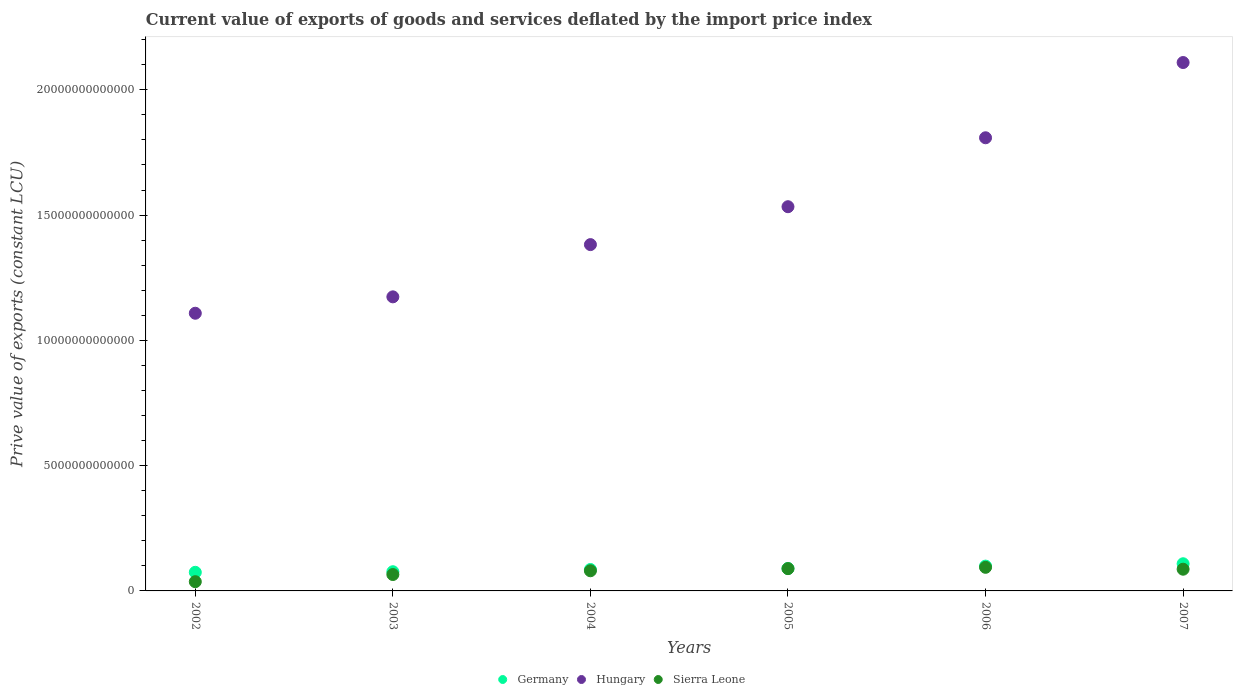What is the prive value of exports in Germany in 2005?
Make the answer very short. 8.96e+11. Across all years, what is the maximum prive value of exports in Germany?
Offer a very short reply. 1.08e+12. Across all years, what is the minimum prive value of exports in Sierra Leone?
Make the answer very short. 3.69e+11. In which year was the prive value of exports in Sierra Leone minimum?
Offer a terse response. 2002. What is the total prive value of exports in Sierra Leone in the graph?
Your answer should be very brief. 4.52e+12. What is the difference between the prive value of exports in Germany in 2003 and that in 2005?
Offer a terse response. -1.30e+11. What is the difference between the prive value of exports in Sierra Leone in 2004 and the prive value of exports in Germany in 2007?
Offer a terse response. -2.80e+11. What is the average prive value of exports in Hungary per year?
Offer a very short reply. 1.52e+13. In the year 2006, what is the difference between the prive value of exports in Hungary and prive value of exports in Sierra Leone?
Offer a very short reply. 1.71e+13. What is the ratio of the prive value of exports in Hungary in 2004 to that in 2006?
Provide a short and direct response. 0.76. What is the difference between the highest and the second highest prive value of exports in Germany?
Provide a short and direct response. 9.41e+1. What is the difference between the highest and the lowest prive value of exports in Hungary?
Offer a very short reply. 1.00e+13. Does the prive value of exports in Hungary monotonically increase over the years?
Offer a terse response. Yes. Is the prive value of exports in Sierra Leone strictly less than the prive value of exports in Germany over the years?
Keep it short and to the point. Yes. How many dotlines are there?
Offer a terse response. 3. How many years are there in the graph?
Your answer should be very brief. 6. What is the difference between two consecutive major ticks on the Y-axis?
Ensure brevity in your answer.  5.00e+12. Are the values on the major ticks of Y-axis written in scientific E-notation?
Provide a short and direct response. No. Does the graph contain any zero values?
Make the answer very short. No. How many legend labels are there?
Offer a very short reply. 3. What is the title of the graph?
Your answer should be very brief. Current value of exports of goods and services deflated by the import price index. Does "Tuvalu" appear as one of the legend labels in the graph?
Offer a very short reply. No. What is the label or title of the Y-axis?
Your answer should be compact. Prive value of exports (constant LCU). What is the Prive value of exports (constant LCU) of Germany in 2002?
Your answer should be very brief. 7.43e+11. What is the Prive value of exports (constant LCU) in Hungary in 2002?
Your response must be concise. 1.11e+13. What is the Prive value of exports (constant LCU) in Sierra Leone in 2002?
Your answer should be very brief. 3.69e+11. What is the Prive value of exports (constant LCU) of Germany in 2003?
Give a very brief answer. 7.66e+11. What is the Prive value of exports (constant LCU) in Hungary in 2003?
Offer a very short reply. 1.17e+13. What is the Prive value of exports (constant LCU) in Sierra Leone in 2003?
Your answer should be compact. 6.54e+11. What is the Prive value of exports (constant LCU) of Germany in 2004?
Offer a terse response. 8.56e+11. What is the Prive value of exports (constant LCU) in Hungary in 2004?
Keep it short and to the point. 1.38e+13. What is the Prive value of exports (constant LCU) in Sierra Leone in 2004?
Offer a terse response. 8.04e+11. What is the Prive value of exports (constant LCU) of Germany in 2005?
Provide a succinct answer. 8.96e+11. What is the Prive value of exports (constant LCU) of Hungary in 2005?
Offer a terse response. 1.53e+13. What is the Prive value of exports (constant LCU) in Sierra Leone in 2005?
Keep it short and to the point. 8.90e+11. What is the Prive value of exports (constant LCU) of Germany in 2006?
Ensure brevity in your answer.  9.90e+11. What is the Prive value of exports (constant LCU) of Hungary in 2006?
Your response must be concise. 1.81e+13. What is the Prive value of exports (constant LCU) in Sierra Leone in 2006?
Give a very brief answer. 9.42e+11. What is the Prive value of exports (constant LCU) of Germany in 2007?
Provide a succinct answer. 1.08e+12. What is the Prive value of exports (constant LCU) of Hungary in 2007?
Your answer should be compact. 2.11e+13. What is the Prive value of exports (constant LCU) in Sierra Leone in 2007?
Offer a terse response. 8.66e+11. Across all years, what is the maximum Prive value of exports (constant LCU) in Germany?
Provide a short and direct response. 1.08e+12. Across all years, what is the maximum Prive value of exports (constant LCU) in Hungary?
Make the answer very short. 2.11e+13. Across all years, what is the maximum Prive value of exports (constant LCU) of Sierra Leone?
Your answer should be compact. 9.42e+11. Across all years, what is the minimum Prive value of exports (constant LCU) in Germany?
Offer a very short reply. 7.43e+11. Across all years, what is the minimum Prive value of exports (constant LCU) of Hungary?
Offer a very short reply. 1.11e+13. Across all years, what is the minimum Prive value of exports (constant LCU) of Sierra Leone?
Your answer should be compact. 3.69e+11. What is the total Prive value of exports (constant LCU) of Germany in the graph?
Offer a very short reply. 5.34e+12. What is the total Prive value of exports (constant LCU) of Hungary in the graph?
Your answer should be compact. 9.12e+13. What is the total Prive value of exports (constant LCU) in Sierra Leone in the graph?
Keep it short and to the point. 4.52e+12. What is the difference between the Prive value of exports (constant LCU) of Germany in 2002 and that in 2003?
Your answer should be compact. -2.31e+1. What is the difference between the Prive value of exports (constant LCU) of Hungary in 2002 and that in 2003?
Provide a succinct answer. -6.55e+11. What is the difference between the Prive value of exports (constant LCU) in Sierra Leone in 2002 and that in 2003?
Provide a succinct answer. -2.86e+11. What is the difference between the Prive value of exports (constant LCU) of Germany in 2002 and that in 2004?
Provide a succinct answer. -1.13e+11. What is the difference between the Prive value of exports (constant LCU) in Hungary in 2002 and that in 2004?
Ensure brevity in your answer.  -2.74e+12. What is the difference between the Prive value of exports (constant LCU) of Sierra Leone in 2002 and that in 2004?
Your answer should be compact. -4.35e+11. What is the difference between the Prive value of exports (constant LCU) in Germany in 2002 and that in 2005?
Your answer should be compact. -1.53e+11. What is the difference between the Prive value of exports (constant LCU) in Hungary in 2002 and that in 2005?
Provide a short and direct response. -4.25e+12. What is the difference between the Prive value of exports (constant LCU) in Sierra Leone in 2002 and that in 2005?
Make the answer very short. -5.21e+11. What is the difference between the Prive value of exports (constant LCU) of Germany in 2002 and that in 2006?
Offer a very short reply. -2.47e+11. What is the difference between the Prive value of exports (constant LCU) of Hungary in 2002 and that in 2006?
Your response must be concise. -7.00e+12. What is the difference between the Prive value of exports (constant LCU) of Sierra Leone in 2002 and that in 2006?
Your answer should be compact. -5.73e+11. What is the difference between the Prive value of exports (constant LCU) of Germany in 2002 and that in 2007?
Provide a short and direct response. -3.41e+11. What is the difference between the Prive value of exports (constant LCU) in Hungary in 2002 and that in 2007?
Your answer should be compact. -1.00e+13. What is the difference between the Prive value of exports (constant LCU) in Sierra Leone in 2002 and that in 2007?
Offer a very short reply. -4.98e+11. What is the difference between the Prive value of exports (constant LCU) of Germany in 2003 and that in 2004?
Your answer should be compact. -8.95e+1. What is the difference between the Prive value of exports (constant LCU) of Hungary in 2003 and that in 2004?
Offer a terse response. -2.08e+12. What is the difference between the Prive value of exports (constant LCU) in Sierra Leone in 2003 and that in 2004?
Your response must be concise. -1.50e+11. What is the difference between the Prive value of exports (constant LCU) of Germany in 2003 and that in 2005?
Keep it short and to the point. -1.30e+11. What is the difference between the Prive value of exports (constant LCU) of Hungary in 2003 and that in 2005?
Your response must be concise. -3.60e+12. What is the difference between the Prive value of exports (constant LCU) in Sierra Leone in 2003 and that in 2005?
Ensure brevity in your answer.  -2.35e+11. What is the difference between the Prive value of exports (constant LCU) in Germany in 2003 and that in 2006?
Provide a short and direct response. -2.24e+11. What is the difference between the Prive value of exports (constant LCU) of Hungary in 2003 and that in 2006?
Offer a very short reply. -6.35e+12. What is the difference between the Prive value of exports (constant LCU) in Sierra Leone in 2003 and that in 2006?
Give a very brief answer. -2.88e+11. What is the difference between the Prive value of exports (constant LCU) in Germany in 2003 and that in 2007?
Offer a terse response. -3.18e+11. What is the difference between the Prive value of exports (constant LCU) in Hungary in 2003 and that in 2007?
Provide a succinct answer. -9.35e+12. What is the difference between the Prive value of exports (constant LCU) of Sierra Leone in 2003 and that in 2007?
Provide a succinct answer. -2.12e+11. What is the difference between the Prive value of exports (constant LCU) in Germany in 2004 and that in 2005?
Offer a very short reply. -4.09e+1. What is the difference between the Prive value of exports (constant LCU) of Hungary in 2004 and that in 2005?
Make the answer very short. -1.51e+12. What is the difference between the Prive value of exports (constant LCU) in Sierra Leone in 2004 and that in 2005?
Ensure brevity in your answer.  -8.55e+1. What is the difference between the Prive value of exports (constant LCU) of Germany in 2004 and that in 2006?
Your response must be concise. -1.34e+11. What is the difference between the Prive value of exports (constant LCU) in Hungary in 2004 and that in 2006?
Provide a short and direct response. -4.26e+12. What is the difference between the Prive value of exports (constant LCU) of Sierra Leone in 2004 and that in 2006?
Ensure brevity in your answer.  -1.38e+11. What is the difference between the Prive value of exports (constant LCU) of Germany in 2004 and that in 2007?
Offer a very short reply. -2.29e+11. What is the difference between the Prive value of exports (constant LCU) of Hungary in 2004 and that in 2007?
Your response must be concise. -7.27e+12. What is the difference between the Prive value of exports (constant LCU) in Sierra Leone in 2004 and that in 2007?
Make the answer very short. -6.23e+1. What is the difference between the Prive value of exports (constant LCU) of Germany in 2005 and that in 2006?
Offer a terse response. -9.36e+1. What is the difference between the Prive value of exports (constant LCU) in Hungary in 2005 and that in 2006?
Offer a very short reply. -2.75e+12. What is the difference between the Prive value of exports (constant LCU) of Sierra Leone in 2005 and that in 2006?
Ensure brevity in your answer.  -5.21e+1. What is the difference between the Prive value of exports (constant LCU) of Germany in 2005 and that in 2007?
Keep it short and to the point. -1.88e+11. What is the difference between the Prive value of exports (constant LCU) of Hungary in 2005 and that in 2007?
Provide a short and direct response. -5.75e+12. What is the difference between the Prive value of exports (constant LCU) of Sierra Leone in 2005 and that in 2007?
Offer a terse response. 2.32e+1. What is the difference between the Prive value of exports (constant LCU) in Germany in 2006 and that in 2007?
Your response must be concise. -9.41e+1. What is the difference between the Prive value of exports (constant LCU) of Hungary in 2006 and that in 2007?
Make the answer very short. -3.00e+12. What is the difference between the Prive value of exports (constant LCU) in Sierra Leone in 2006 and that in 2007?
Your answer should be very brief. 7.53e+1. What is the difference between the Prive value of exports (constant LCU) of Germany in 2002 and the Prive value of exports (constant LCU) of Hungary in 2003?
Make the answer very short. -1.10e+13. What is the difference between the Prive value of exports (constant LCU) in Germany in 2002 and the Prive value of exports (constant LCU) in Sierra Leone in 2003?
Ensure brevity in your answer.  8.88e+1. What is the difference between the Prive value of exports (constant LCU) in Hungary in 2002 and the Prive value of exports (constant LCU) in Sierra Leone in 2003?
Offer a very short reply. 1.04e+13. What is the difference between the Prive value of exports (constant LCU) in Germany in 2002 and the Prive value of exports (constant LCU) in Hungary in 2004?
Your response must be concise. -1.31e+13. What is the difference between the Prive value of exports (constant LCU) in Germany in 2002 and the Prive value of exports (constant LCU) in Sierra Leone in 2004?
Your answer should be compact. -6.11e+1. What is the difference between the Prive value of exports (constant LCU) of Hungary in 2002 and the Prive value of exports (constant LCU) of Sierra Leone in 2004?
Your response must be concise. 1.03e+13. What is the difference between the Prive value of exports (constant LCU) of Germany in 2002 and the Prive value of exports (constant LCU) of Hungary in 2005?
Ensure brevity in your answer.  -1.46e+13. What is the difference between the Prive value of exports (constant LCU) of Germany in 2002 and the Prive value of exports (constant LCU) of Sierra Leone in 2005?
Provide a succinct answer. -1.47e+11. What is the difference between the Prive value of exports (constant LCU) of Hungary in 2002 and the Prive value of exports (constant LCU) of Sierra Leone in 2005?
Provide a succinct answer. 1.02e+13. What is the difference between the Prive value of exports (constant LCU) in Germany in 2002 and the Prive value of exports (constant LCU) in Hungary in 2006?
Provide a succinct answer. -1.73e+13. What is the difference between the Prive value of exports (constant LCU) in Germany in 2002 and the Prive value of exports (constant LCU) in Sierra Leone in 2006?
Offer a terse response. -1.99e+11. What is the difference between the Prive value of exports (constant LCU) in Hungary in 2002 and the Prive value of exports (constant LCU) in Sierra Leone in 2006?
Your response must be concise. 1.01e+13. What is the difference between the Prive value of exports (constant LCU) of Germany in 2002 and the Prive value of exports (constant LCU) of Hungary in 2007?
Ensure brevity in your answer.  -2.03e+13. What is the difference between the Prive value of exports (constant LCU) of Germany in 2002 and the Prive value of exports (constant LCU) of Sierra Leone in 2007?
Offer a very short reply. -1.23e+11. What is the difference between the Prive value of exports (constant LCU) of Hungary in 2002 and the Prive value of exports (constant LCU) of Sierra Leone in 2007?
Your answer should be compact. 1.02e+13. What is the difference between the Prive value of exports (constant LCU) in Germany in 2003 and the Prive value of exports (constant LCU) in Hungary in 2004?
Offer a terse response. -1.31e+13. What is the difference between the Prive value of exports (constant LCU) in Germany in 2003 and the Prive value of exports (constant LCU) in Sierra Leone in 2004?
Offer a terse response. -3.80e+1. What is the difference between the Prive value of exports (constant LCU) in Hungary in 2003 and the Prive value of exports (constant LCU) in Sierra Leone in 2004?
Offer a very short reply. 1.09e+13. What is the difference between the Prive value of exports (constant LCU) in Germany in 2003 and the Prive value of exports (constant LCU) in Hungary in 2005?
Your answer should be compact. -1.46e+13. What is the difference between the Prive value of exports (constant LCU) of Germany in 2003 and the Prive value of exports (constant LCU) of Sierra Leone in 2005?
Provide a short and direct response. -1.23e+11. What is the difference between the Prive value of exports (constant LCU) in Hungary in 2003 and the Prive value of exports (constant LCU) in Sierra Leone in 2005?
Offer a terse response. 1.08e+13. What is the difference between the Prive value of exports (constant LCU) in Germany in 2003 and the Prive value of exports (constant LCU) in Hungary in 2006?
Your answer should be compact. -1.73e+13. What is the difference between the Prive value of exports (constant LCU) of Germany in 2003 and the Prive value of exports (constant LCU) of Sierra Leone in 2006?
Ensure brevity in your answer.  -1.76e+11. What is the difference between the Prive value of exports (constant LCU) of Hungary in 2003 and the Prive value of exports (constant LCU) of Sierra Leone in 2006?
Offer a very short reply. 1.08e+13. What is the difference between the Prive value of exports (constant LCU) of Germany in 2003 and the Prive value of exports (constant LCU) of Hungary in 2007?
Your answer should be very brief. -2.03e+13. What is the difference between the Prive value of exports (constant LCU) in Germany in 2003 and the Prive value of exports (constant LCU) in Sierra Leone in 2007?
Your answer should be compact. -1.00e+11. What is the difference between the Prive value of exports (constant LCU) in Hungary in 2003 and the Prive value of exports (constant LCU) in Sierra Leone in 2007?
Offer a terse response. 1.09e+13. What is the difference between the Prive value of exports (constant LCU) in Germany in 2004 and the Prive value of exports (constant LCU) in Hungary in 2005?
Provide a succinct answer. -1.45e+13. What is the difference between the Prive value of exports (constant LCU) in Germany in 2004 and the Prive value of exports (constant LCU) in Sierra Leone in 2005?
Provide a succinct answer. -3.40e+1. What is the difference between the Prive value of exports (constant LCU) of Hungary in 2004 and the Prive value of exports (constant LCU) of Sierra Leone in 2005?
Your answer should be very brief. 1.29e+13. What is the difference between the Prive value of exports (constant LCU) of Germany in 2004 and the Prive value of exports (constant LCU) of Hungary in 2006?
Give a very brief answer. -1.72e+13. What is the difference between the Prive value of exports (constant LCU) in Germany in 2004 and the Prive value of exports (constant LCU) in Sierra Leone in 2006?
Keep it short and to the point. -8.61e+1. What is the difference between the Prive value of exports (constant LCU) in Hungary in 2004 and the Prive value of exports (constant LCU) in Sierra Leone in 2006?
Give a very brief answer. 1.29e+13. What is the difference between the Prive value of exports (constant LCU) in Germany in 2004 and the Prive value of exports (constant LCU) in Hungary in 2007?
Provide a succinct answer. -2.02e+13. What is the difference between the Prive value of exports (constant LCU) of Germany in 2004 and the Prive value of exports (constant LCU) of Sierra Leone in 2007?
Your response must be concise. -1.08e+1. What is the difference between the Prive value of exports (constant LCU) in Hungary in 2004 and the Prive value of exports (constant LCU) in Sierra Leone in 2007?
Give a very brief answer. 1.30e+13. What is the difference between the Prive value of exports (constant LCU) in Germany in 2005 and the Prive value of exports (constant LCU) in Hungary in 2006?
Offer a very short reply. -1.72e+13. What is the difference between the Prive value of exports (constant LCU) in Germany in 2005 and the Prive value of exports (constant LCU) in Sierra Leone in 2006?
Ensure brevity in your answer.  -4.52e+1. What is the difference between the Prive value of exports (constant LCU) in Hungary in 2005 and the Prive value of exports (constant LCU) in Sierra Leone in 2006?
Offer a terse response. 1.44e+13. What is the difference between the Prive value of exports (constant LCU) of Germany in 2005 and the Prive value of exports (constant LCU) of Hungary in 2007?
Offer a terse response. -2.02e+13. What is the difference between the Prive value of exports (constant LCU) in Germany in 2005 and the Prive value of exports (constant LCU) in Sierra Leone in 2007?
Keep it short and to the point. 3.01e+1. What is the difference between the Prive value of exports (constant LCU) of Hungary in 2005 and the Prive value of exports (constant LCU) of Sierra Leone in 2007?
Provide a succinct answer. 1.45e+13. What is the difference between the Prive value of exports (constant LCU) in Germany in 2006 and the Prive value of exports (constant LCU) in Hungary in 2007?
Provide a succinct answer. -2.01e+13. What is the difference between the Prive value of exports (constant LCU) in Germany in 2006 and the Prive value of exports (constant LCU) in Sierra Leone in 2007?
Provide a short and direct response. 1.24e+11. What is the difference between the Prive value of exports (constant LCU) of Hungary in 2006 and the Prive value of exports (constant LCU) of Sierra Leone in 2007?
Offer a terse response. 1.72e+13. What is the average Prive value of exports (constant LCU) in Germany per year?
Make the answer very short. 8.89e+11. What is the average Prive value of exports (constant LCU) in Hungary per year?
Give a very brief answer. 1.52e+13. What is the average Prive value of exports (constant LCU) in Sierra Leone per year?
Keep it short and to the point. 7.54e+11. In the year 2002, what is the difference between the Prive value of exports (constant LCU) of Germany and Prive value of exports (constant LCU) of Hungary?
Your response must be concise. -1.03e+13. In the year 2002, what is the difference between the Prive value of exports (constant LCU) of Germany and Prive value of exports (constant LCU) of Sierra Leone?
Your answer should be very brief. 3.74e+11. In the year 2002, what is the difference between the Prive value of exports (constant LCU) in Hungary and Prive value of exports (constant LCU) in Sierra Leone?
Your response must be concise. 1.07e+13. In the year 2003, what is the difference between the Prive value of exports (constant LCU) of Germany and Prive value of exports (constant LCU) of Hungary?
Your answer should be compact. -1.10e+13. In the year 2003, what is the difference between the Prive value of exports (constant LCU) in Germany and Prive value of exports (constant LCU) in Sierra Leone?
Keep it short and to the point. 1.12e+11. In the year 2003, what is the difference between the Prive value of exports (constant LCU) of Hungary and Prive value of exports (constant LCU) of Sierra Leone?
Keep it short and to the point. 1.11e+13. In the year 2004, what is the difference between the Prive value of exports (constant LCU) of Germany and Prive value of exports (constant LCU) of Hungary?
Provide a succinct answer. -1.30e+13. In the year 2004, what is the difference between the Prive value of exports (constant LCU) of Germany and Prive value of exports (constant LCU) of Sierra Leone?
Offer a terse response. 5.15e+1. In the year 2004, what is the difference between the Prive value of exports (constant LCU) of Hungary and Prive value of exports (constant LCU) of Sierra Leone?
Make the answer very short. 1.30e+13. In the year 2005, what is the difference between the Prive value of exports (constant LCU) in Germany and Prive value of exports (constant LCU) in Hungary?
Your answer should be compact. -1.44e+13. In the year 2005, what is the difference between the Prive value of exports (constant LCU) of Germany and Prive value of exports (constant LCU) of Sierra Leone?
Give a very brief answer. 6.90e+09. In the year 2005, what is the difference between the Prive value of exports (constant LCU) in Hungary and Prive value of exports (constant LCU) in Sierra Leone?
Give a very brief answer. 1.44e+13. In the year 2006, what is the difference between the Prive value of exports (constant LCU) in Germany and Prive value of exports (constant LCU) in Hungary?
Make the answer very short. -1.71e+13. In the year 2006, what is the difference between the Prive value of exports (constant LCU) in Germany and Prive value of exports (constant LCU) in Sierra Leone?
Your answer should be very brief. 4.83e+1. In the year 2006, what is the difference between the Prive value of exports (constant LCU) in Hungary and Prive value of exports (constant LCU) in Sierra Leone?
Provide a succinct answer. 1.71e+13. In the year 2007, what is the difference between the Prive value of exports (constant LCU) of Germany and Prive value of exports (constant LCU) of Hungary?
Provide a short and direct response. -2.00e+13. In the year 2007, what is the difference between the Prive value of exports (constant LCU) in Germany and Prive value of exports (constant LCU) in Sierra Leone?
Your answer should be compact. 2.18e+11. In the year 2007, what is the difference between the Prive value of exports (constant LCU) of Hungary and Prive value of exports (constant LCU) of Sierra Leone?
Ensure brevity in your answer.  2.02e+13. What is the ratio of the Prive value of exports (constant LCU) in Germany in 2002 to that in 2003?
Offer a very short reply. 0.97. What is the ratio of the Prive value of exports (constant LCU) of Hungary in 2002 to that in 2003?
Keep it short and to the point. 0.94. What is the ratio of the Prive value of exports (constant LCU) of Sierra Leone in 2002 to that in 2003?
Offer a terse response. 0.56. What is the ratio of the Prive value of exports (constant LCU) of Germany in 2002 to that in 2004?
Provide a short and direct response. 0.87. What is the ratio of the Prive value of exports (constant LCU) in Hungary in 2002 to that in 2004?
Your response must be concise. 0.8. What is the ratio of the Prive value of exports (constant LCU) in Sierra Leone in 2002 to that in 2004?
Your answer should be compact. 0.46. What is the ratio of the Prive value of exports (constant LCU) of Germany in 2002 to that in 2005?
Offer a terse response. 0.83. What is the ratio of the Prive value of exports (constant LCU) of Hungary in 2002 to that in 2005?
Offer a very short reply. 0.72. What is the ratio of the Prive value of exports (constant LCU) in Sierra Leone in 2002 to that in 2005?
Give a very brief answer. 0.41. What is the ratio of the Prive value of exports (constant LCU) of Germany in 2002 to that in 2006?
Offer a very short reply. 0.75. What is the ratio of the Prive value of exports (constant LCU) of Hungary in 2002 to that in 2006?
Offer a terse response. 0.61. What is the ratio of the Prive value of exports (constant LCU) of Sierra Leone in 2002 to that in 2006?
Your response must be concise. 0.39. What is the ratio of the Prive value of exports (constant LCU) of Germany in 2002 to that in 2007?
Offer a very short reply. 0.69. What is the ratio of the Prive value of exports (constant LCU) in Hungary in 2002 to that in 2007?
Give a very brief answer. 0.53. What is the ratio of the Prive value of exports (constant LCU) of Sierra Leone in 2002 to that in 2007?
Make the answer very short. 0.43. What is the ratio of the Prive value of exports (constant LCU) of Germany in 2003 to that in 2004?
Provide a succinct answer. 0.9. What is the ratio of the Prive value of exports (constant LCU) of Hungary in 2003 to that in 2004?
Your answer should be compact. 0.85. What is the ratio of the Prive value of exports (constant LCU) in Sierra Leone in 2003 to that in 2004?
Offer a terse response. 0.81. What is the ratio of the Prive value of exports (constant LCU) in Germany in 2003 to that in 2005?
Your response must be concise. 0.85. What is the ratio of the Prive value of exports (constant LCU) in Hungary in 2003 to that in 2005?
Provide a succinct answer. 0.77. What is the ratio of the Prive value of exports (constant LCU) in Sierra Leone in 2003 to that in 2005?
Offer a very short reply. 0.74. What is the ratio of the Prive value of exports (constant LCU) in Germany in 2003 to that in 2006?
Provide a short and direct response. 0.77. What is the ratio of the Prive value of exports (constant LCU) of Hungary in 2003 to that in 2006?
Provide a succinct answer. 0.65. What is the ratio of the Prive value of exports (constant LCU) of Sierra Leone in 2003 to that in 2006?
Your response must be concise. 0.69. What is the ratio of the Prive value of exports (constant LCU) in Germany in 2003 to that in 2007?
Your answer should be very brief. 0.71. What is the ratio of the Prive value of exports (constant LCU) in Hungary in 2003 to that in 2007?
Ensure brevity in your answer.  0.56. What is the ratio of the Prive value of exports (constant LCU) of Sierra Leone in 2003 to that in 2007?
Your answer should be compact. 0.76. What is the ratio of the Prive value of exports (constant LCU) of Germany in 2004 to that in 2005?
Provide a short and direct response. 0.95. What is the ratio of the Prive value of exports (constant LCU) in Hungary in 2004 to that in 2005?
Provide a short and direct response. 0.9. What is the ratio of the Prive value of exports (constant LCU) of Sierra Leone in 2004 to that in 2005?
Ensure brevity in your answer.  0.9. What is the ratio of the Prive value of exports (constant LCU) in Germany in 2004 to that in 2006?
Offer a very short reply. 0.86. What is the ratio of the Prive value of exports (constant LCU) in Hungary in 2004 to that in 2006?
Your response must be concise. 0.76. What is the ratio of the Prive value of exports (constant LCU) of Sierra Leone in 2004 to that in 2006?
Your answer should be compact. 0.85. What is the ratio of the Prive value of exports (constant LCU) in Germany in 2004 to that in 2007?
Provide a succinct answer. 0.79. What is the ratio of the Prive value of exports (constant LCU) of Hungary in 2004 to that in 2007?
Keep it short and to the point. 0.66. What is the ratio of the Prive value of exports (constant LCU) in Sierra Leone in 2004 to that in 2007?
Ensure brevity in your answer.  0.93. What is the ratio of the Prive value of exports (constant LCU) in Germany in 2005 to that in 2006?
Keep it short and to the point. 0.91. What is the ratio of the Prive value of exports (constant LCU) in Hungary in 2005 to that in 2006?
Keep it short and to the point. 0.85. What is the ratio of the Prive value of exports (constant LCU) in Sierra Leone in 2005 to that in 2006?
Keep it short and to the point. 0.94. What is the ratio of the Prive value of exports (constant LCU) of Germany in 2005 to that in 2007?
Provide a short and direct response. 0.83. What is the ratio of the Prive value of exports (constant LCU) in Hungary in 2005 to that in 2007?
Give a very brief answer. 0.73. What is the ratio of the Prive value of exports (constant LCU) of Sierra Leone in 2005 to that in 2007?
Give a very brief answer. 1.03. What is the ratio of the Prive value of exports (constant LCU) in Germany in 2006 to that in 2007?
Your answer should be compact. 0.91. What is the ratio of the Prive value of exports (constant LCU) in Hungary in 2006 to that in 2007?
Your answer should be compact. 0.86. What is the ratio of the Prive value of exports (constant LCU) in Sierra Leone in 2006 to that in 2007?
Give a very brief answer. 1.09. What is the difference between the highest and the second highest Prive value of exports (constant LCU) of Germany?
Your response must be concise. 9.41e+1. What is the difference between the highest and the second highest Prive value of exports (constant LCU) of Hungary?
Give a very brief answer. 3.00e+12. What is the difference between the highest and the second highest Prive value of exports (constant LCU) in Sierra Leone?
Offer a terse response. 5.21e+1. What is the difference between the highest and the lowest Prive value of exports (constant LCU) in Germany?
Provide a succinct answer. 3.41e+11. What is the difference between the highest and the lowest Prive value of exports (constant LCU) of Hungary?
Provide a short and direct response. 1.00e+13. What is the difference between the highest and the lowest Prive value of exports (constant LCU) in Sierra Leone?
Provide a succinct answer. 5.73e+11. 